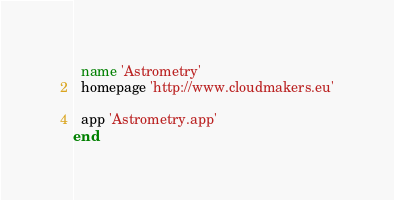<code> <loc_0><loc_0><loc_500><loc_500><_Ruby_>  name 'Astrometry'
  homepage 'http://www.cloudmakers.eu'

  app 'Astrometry.app'
end
</code> 